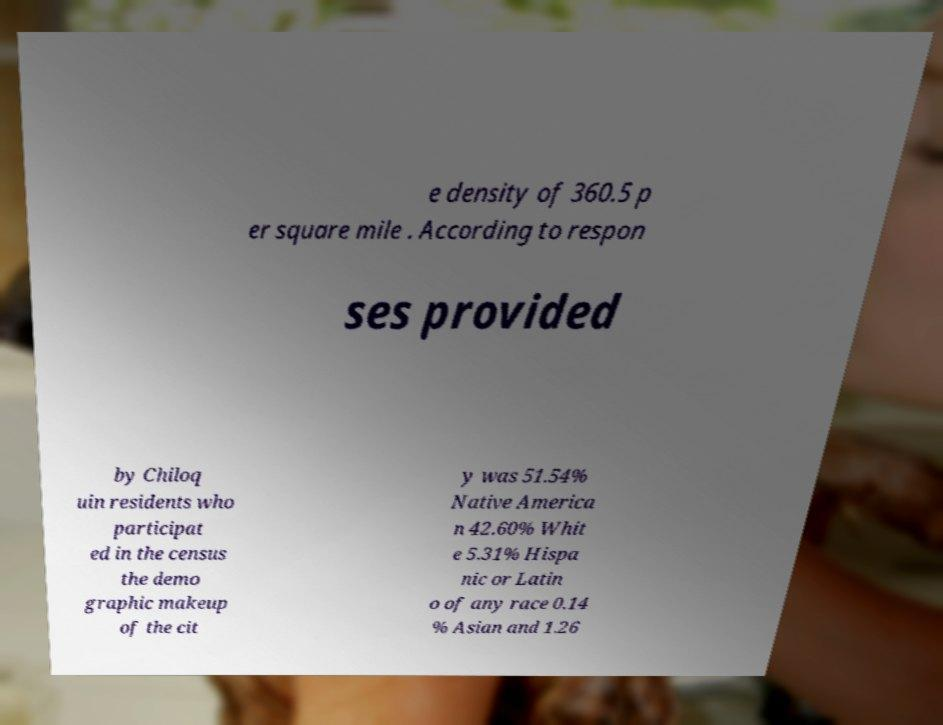What messages or text are displayed in this image? I need them in a readable, typed format. e density of 360.5 p er square mile . According to respon ses provided by Chiloq uin residents who participat ed in the census the demo graphic makeup of the cit y was 51.54% Native America n 42.60% Whit e 5.31% Hispa nic or Latin o of any race 0.14 % Asian and 1.26 